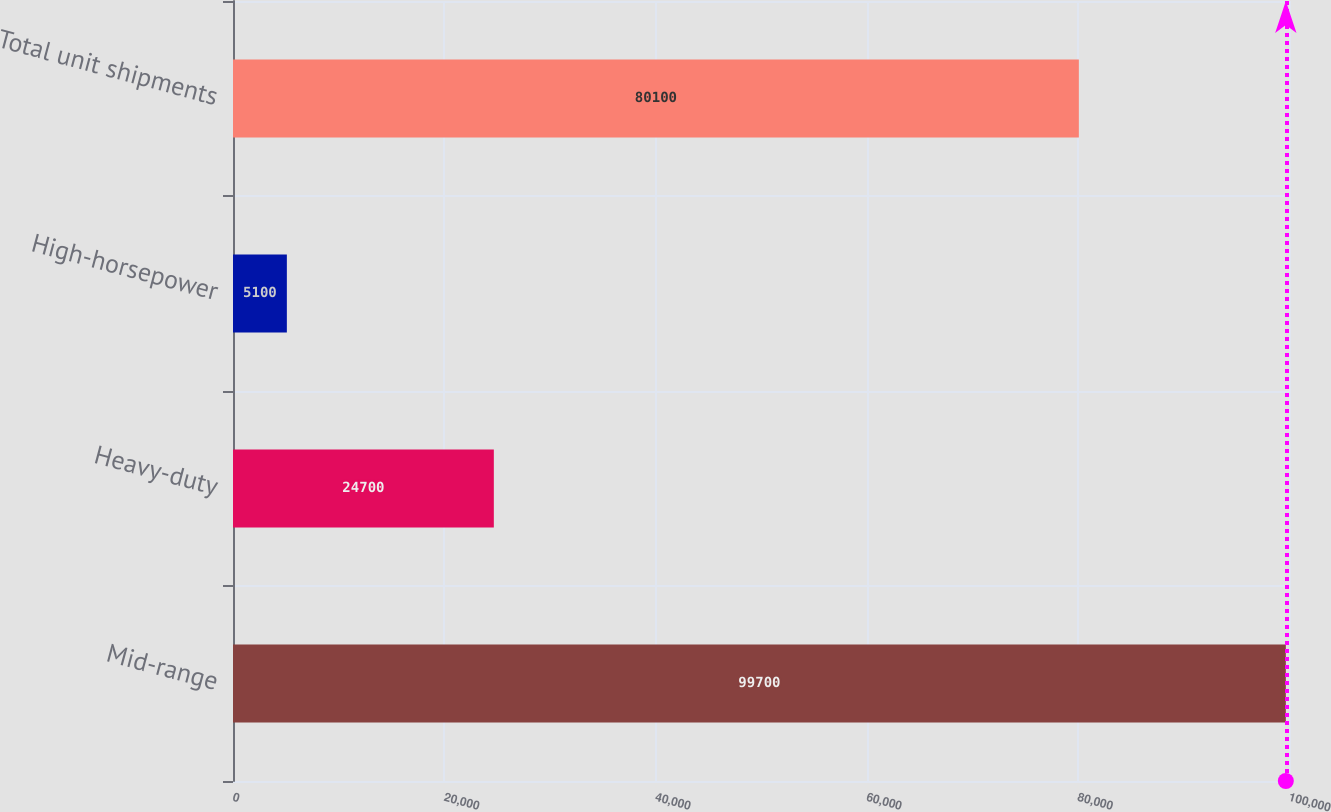<chart> <loc_0><loc_0><loc_500><loc_500><bar_chart><fcel>Mid-range<fcel>Heavy-duty<fcel>High-horsepower<fcel>Total unit shipments<nl><fcel>99700<fcel>24700<fcel>5100<fcel>80100<nl></chart> 